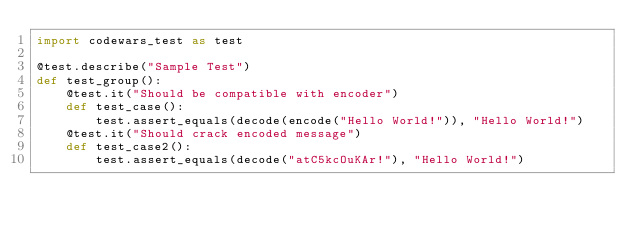Convert code to text. <code><loc_0><loc_0><loc_500><loc_500><_Python_>import codewars_test as test

@test.describe("Sample Test")
def test_group():
    @test.it("Should be compatible with encoder")
    def test_case():
        test.assert_equals(decode(encode("Hello World!")), "Hello World!")
    @test.it("Should crack encoded message")
    def test_case2():
        test.assert_equals(decode("atC5kcOuKAr!"), "Hello World!")</code> 